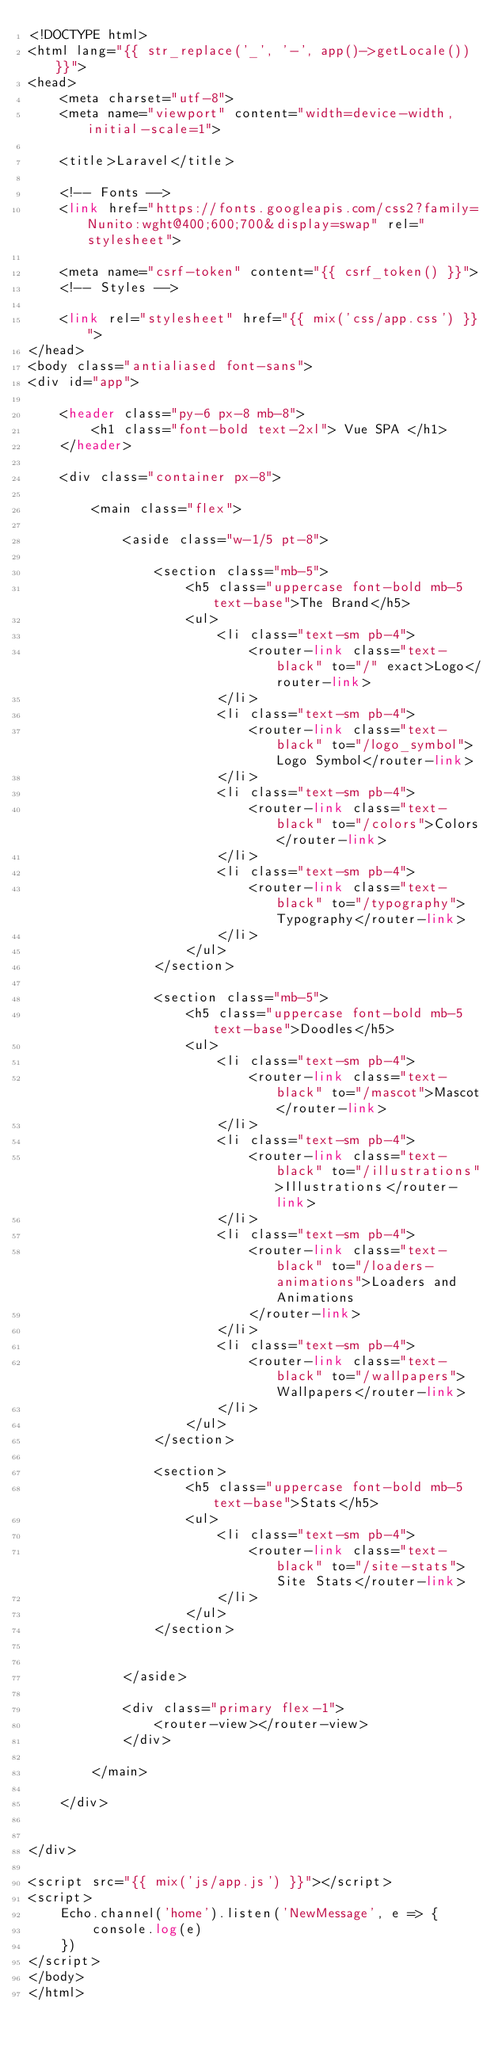Convert code to text. <code><loc_0><loc_0><loc_500><loc_500><_PHP_><!DOCTYPE html>
<html lang="{{ str_replace('_', '-', app()->getLocale()) }}">
<head>
    <meta charset="utf-8">
    <meta name="viewport" content="width=device-width, initial-scale=1">

    <title>Laravel</title>

    <!-- Fonts -->
    <link href="https://fonts.googleapis.com/css2?family=Nunito:wght@400;600;700&display=swap" rel="stylesheet">

    <meta name="csrf-token" content="{{ csrf_token() }}">
    <!-- Styles -->

    <link rel="stylesheet" href="{{ mix('css/app.css') }}">
</head>
<body class="antialiased font-sans">
<div id="app">

    <header class="py-6 px-8 mb-8">
        <h1 class="font-bold text-2xl"> Vue SPA </h1>
    </header>

    <div class="container px-8">

        <main class="flex">

            <aside class="w-1/5 pt-8">

                <section class="mb-5">
                    <h5 class="uppercase font-bold mb-5 text-base">The Brand</h5>
                    <ul>
                        <li class="text-sm pb-4">
                            <router-link class="text-black" to="/" exact>Logo</router-link>
                        </li>
                        <li class="text-sm pb-4">
                            <router-link class="text-black" to="/logo_symbol">Logo Symbol</router-link>
                        </li>
                        <li class="text-sm pb-4">
                            <router-link class="text-black" to="/colors">Colors</router-link>
                        </li>
                        <li class="text-sm pb-4">
                            <router-link class="text-black" to="/typography">Typography</router-link>
                        </li>
                    </ul>
                </section>

                <section class="mb-5">
                    <h5 class="uppercase font-bold mb-5 text-base">Doodles</h5>
                    <ul>
                        <li class="text-sm pb-4">
                            <router-link class="text-black" to="/mascot">Mascot</router-link>
                        </li>
                        <li class="text-sm pb-4">
                            <router-link class="text-black" to="/illustrations">Illustrations</router-link>
                        </li>
                        <li class="text-sm pb-4">
                            <router-link class="text-black" to="/loaders-animations">Loaders and Animations
                            </router-link>
                        </li>
                        <li class="text-sm pb-4">
                            <router-link class="text-black" to="/wallpapers">Wallpapers</router-link>
                        </li>
                    </ul>
                </section>

                <section>
                    <h5 class="uppercase font-bold mb-5 text-base">Stats</h5>
                    <ul>
                        <li class="text-sm pb-4">
                            <router-link class="text-black" to="/site-stats">Site Stats</router-link>
                        </li>
                    </ul>
                </section>


            </aside>

            <div class="primary flex-1">
                <router-view></router-view>
            </div>

        </main>

    </div>


</div>

<script src="{{ mix('js/app.js') }}"></script>
<script>
    Echo.channel('home').listen('NewMessage', e => {
        console.log(e)
    })
</script>
</body>
</html>
</code> 